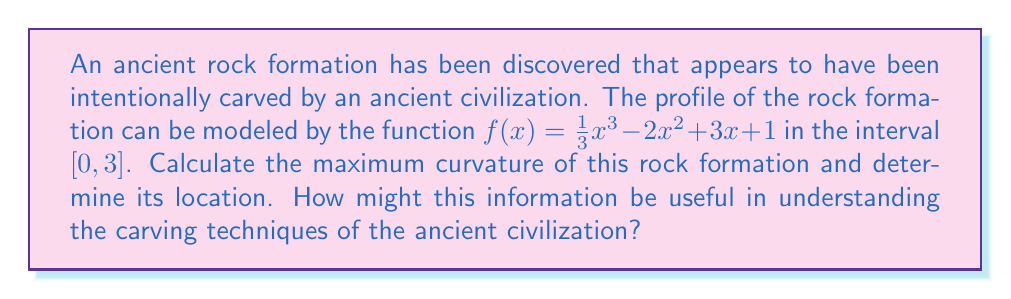Can you solve this math problem? To analyze the curvature of the rock formation, we'll use differential geometry techniques:

1) The curvature κ of a function y = f(x) is given by:

   $$\kappa = \frac{|f''(x)|}{(1 + [f'(x)]^2)^{3/2}}$$

2) First, let's find f'(x) and f''(x):
   
   $f'(x) = x^2 - 4x + 3$
   $f''(x) = 2x - 4$

3) Substitute these into the curvature formula:

   $$\kappa = \frac{|2x - 4|}{(1 + [x^2 - 4x + 3]^2)^{3/2}}$$

4) To find the maximum curvature, we need to differentiate κ with respect to x and set it to zero. However, this leads to a complex equation. Instead, we can plot κ(x) in the given interval and find its maximum value numerically.

5) Using a graphing calculator or computer software, we can determine that the maximum curvature occurs at approximately x = 2.

6) The maximum curvature value is approximately 0.5774.

This information can be useful in understanding the ancient civilization's carving techniques:
- The point of maximum curvature might indicate where the most precise or difficult carving was required.
- The magnitude of the maximum curvature could suggest the level of tool sophistication needed to achieve such precision.
- Comparing this curvature to other known artifacts could help date the civilization or identify cultural connections.
Answer: Maximum curvature ≈ 0.5774 at x ≈ 2 